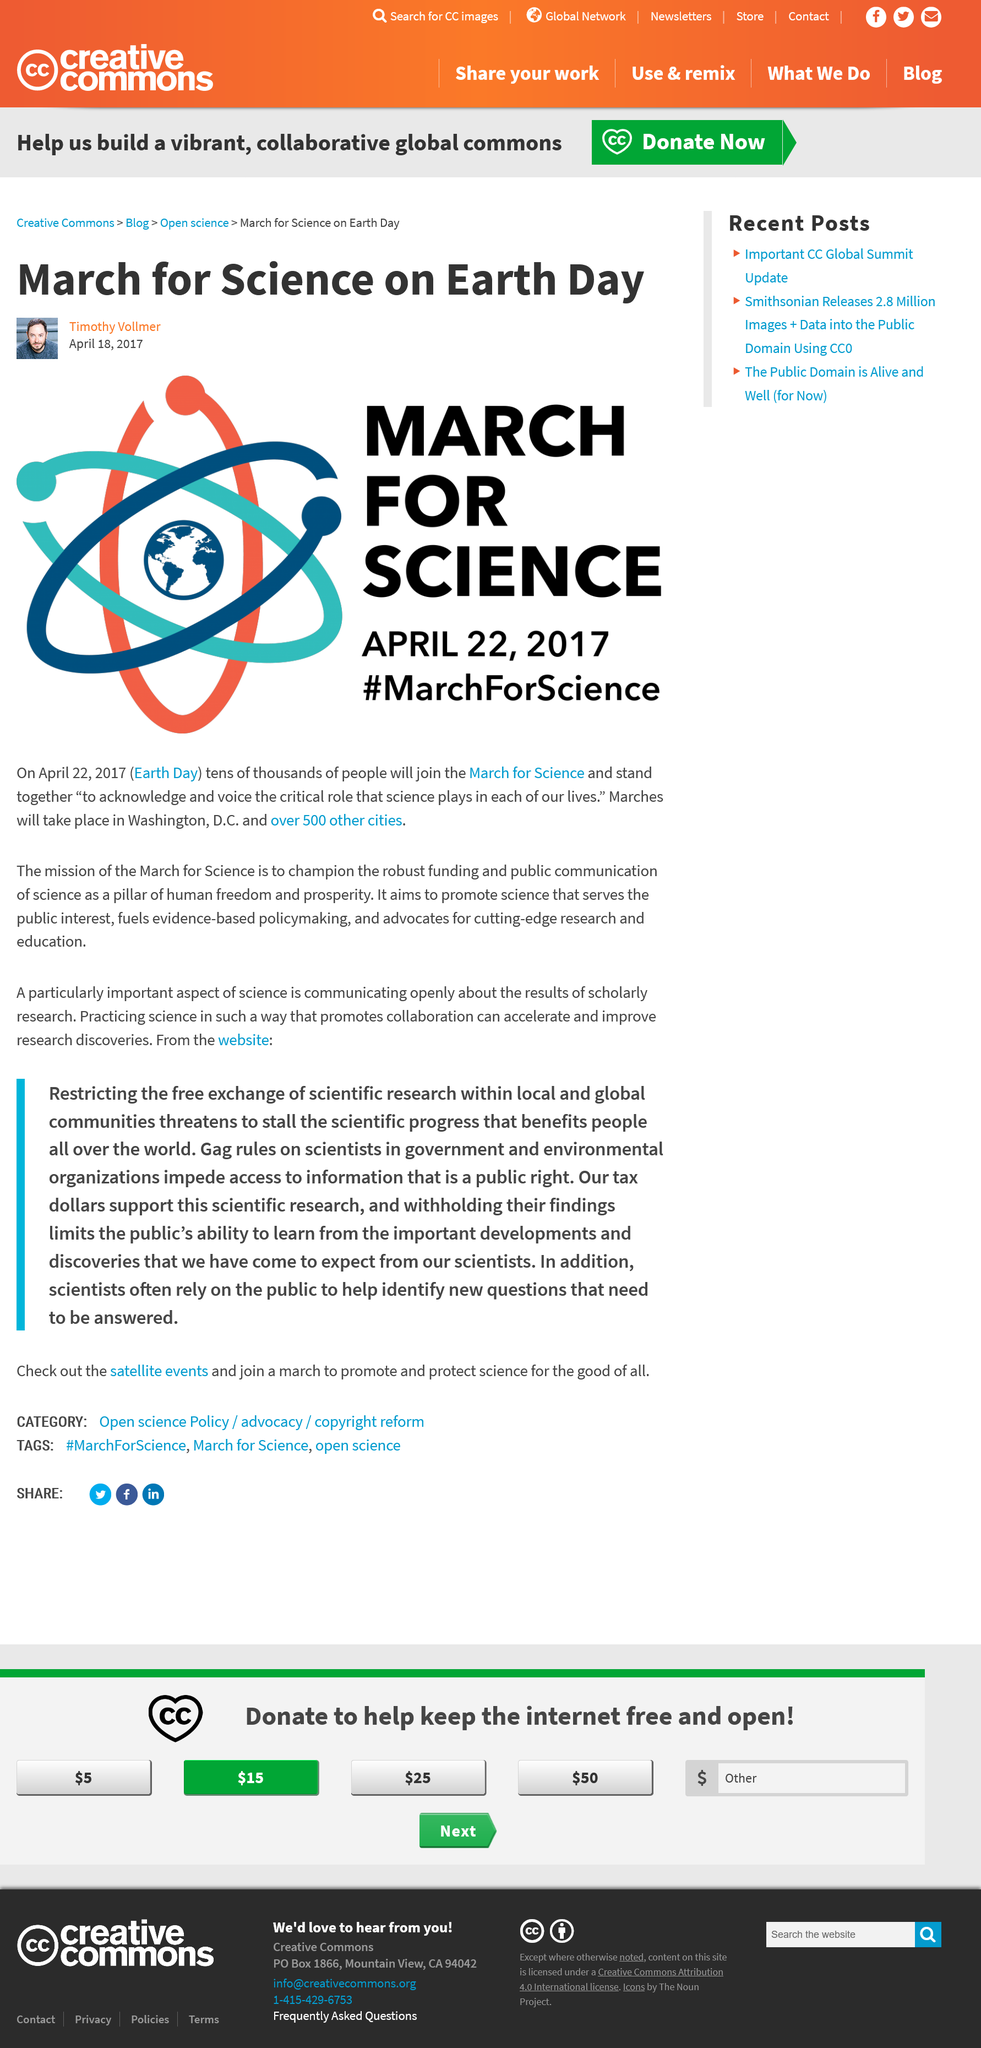Draw attention to some important aspects in this diagram. The March for Science aims to promote the funding and communication of science as a fundamental aspect of human freedom and prosperity. On April 22nd, 2017, which also happens to be Earth Day, the March for Science will take place. Marches will take place in Washington D.C. and in 500 other cities throughout the country. 